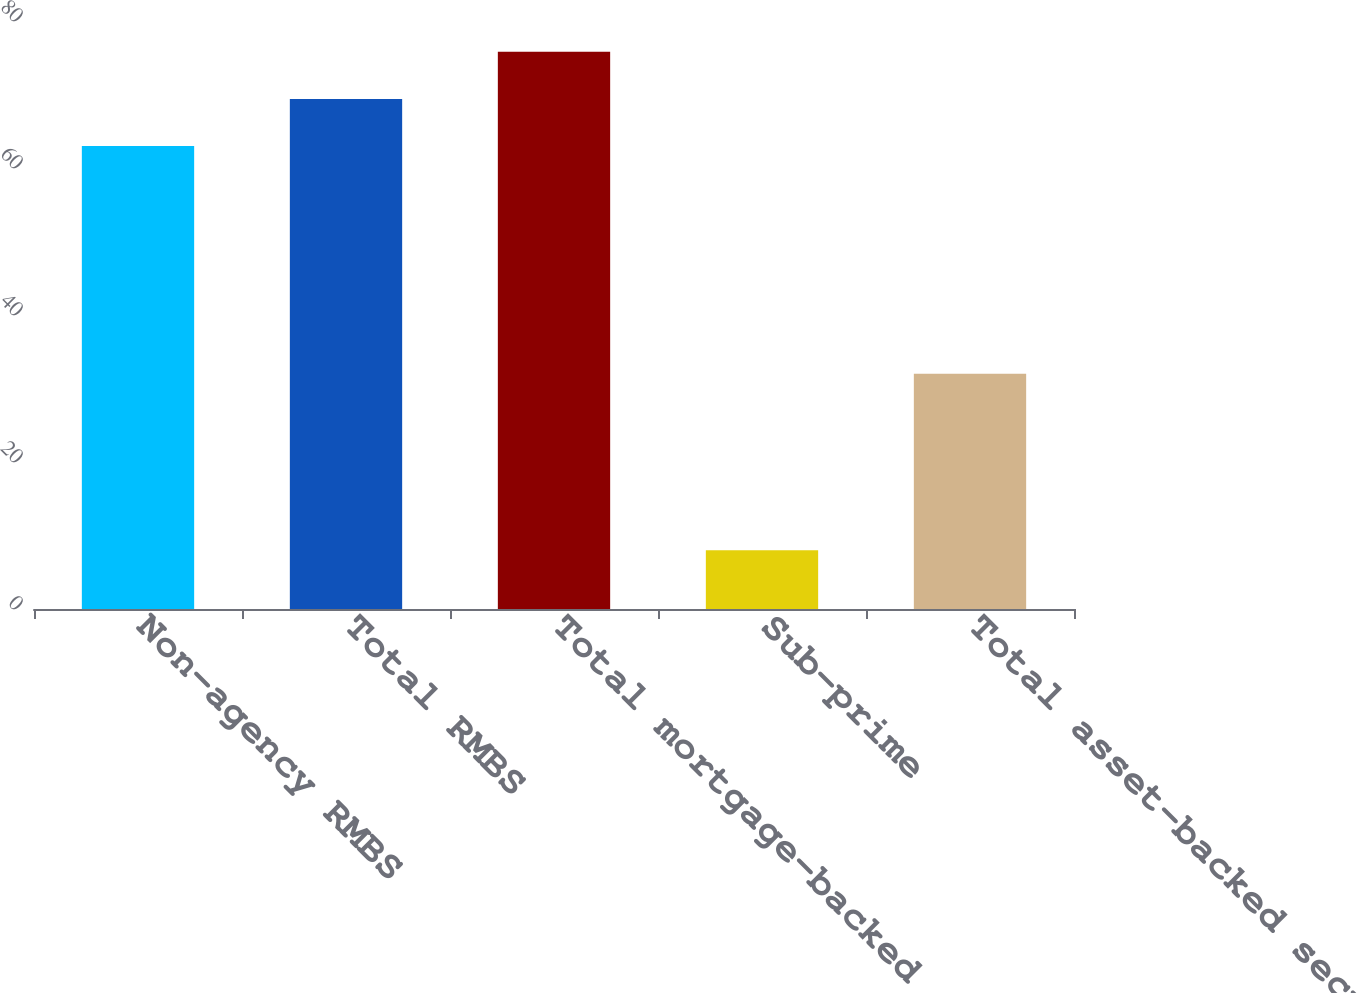Convert chart. <chart><loc_0><loc_0><loc_500><loc_500><bar_chart><fcel>Non-agency RMBS<fcel>Total RMBS<fcel>Total mortgage-backed<fcel>Sub-prime<fcel>Total asset-backed securities<nl><fcel>63<fcel>69.4<fcel>75.8<fcel>8<fcel>32<nl></chart> 